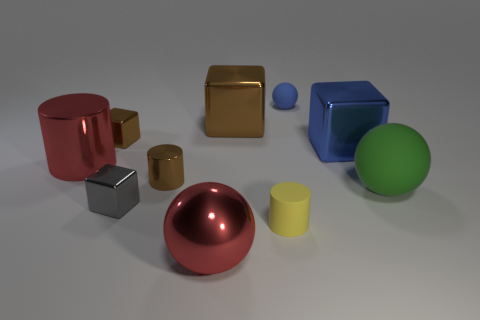There is a ball left of the yellow cylinder; does it have the same size as the red cylinder?
Keep it short and to the point. Yes. Are the small object on the left side of the tiny gray shiny block and the ball to the left of the tiny blue sphere made of the same material?
Provide a succinct answer. Yes. Is there a blue rubber ball of the same size as the green thing?
Your response must be concise. No. There is a large red object left of the sphere to the left of the rubber thing behind the big brown metal block; what is its shape?
Make the answer very short. Cylinder. Is the number of large red spheres that are behind the green matte thing greater than the number of tiny metal cylinders?
Your answer should be compact. No. Is there another big object that has the same shape as the yellow object?
Your answer should be very brief. Yes. Is the gray block made of the same material as the ball left of the big brown object?
Ensure brevity in your answer.  Yes. The tiny matte ball is what color?
Provide a short and direct response. Blue. How many large metallic cylinders are on the right side of the red metal thing to the left of the tiny brown metallic object that is behind the big cylinder?
Ensure brevity in your answer.  0. Are there any tiny gray blocks on the right side of the small metallic cylinder?
Provide a succinct answer. No. 